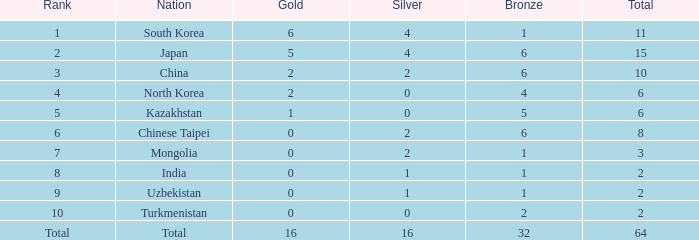What rank is Turkmenistan, who had 0 silver's and Less than 2 golds? 10.0. 